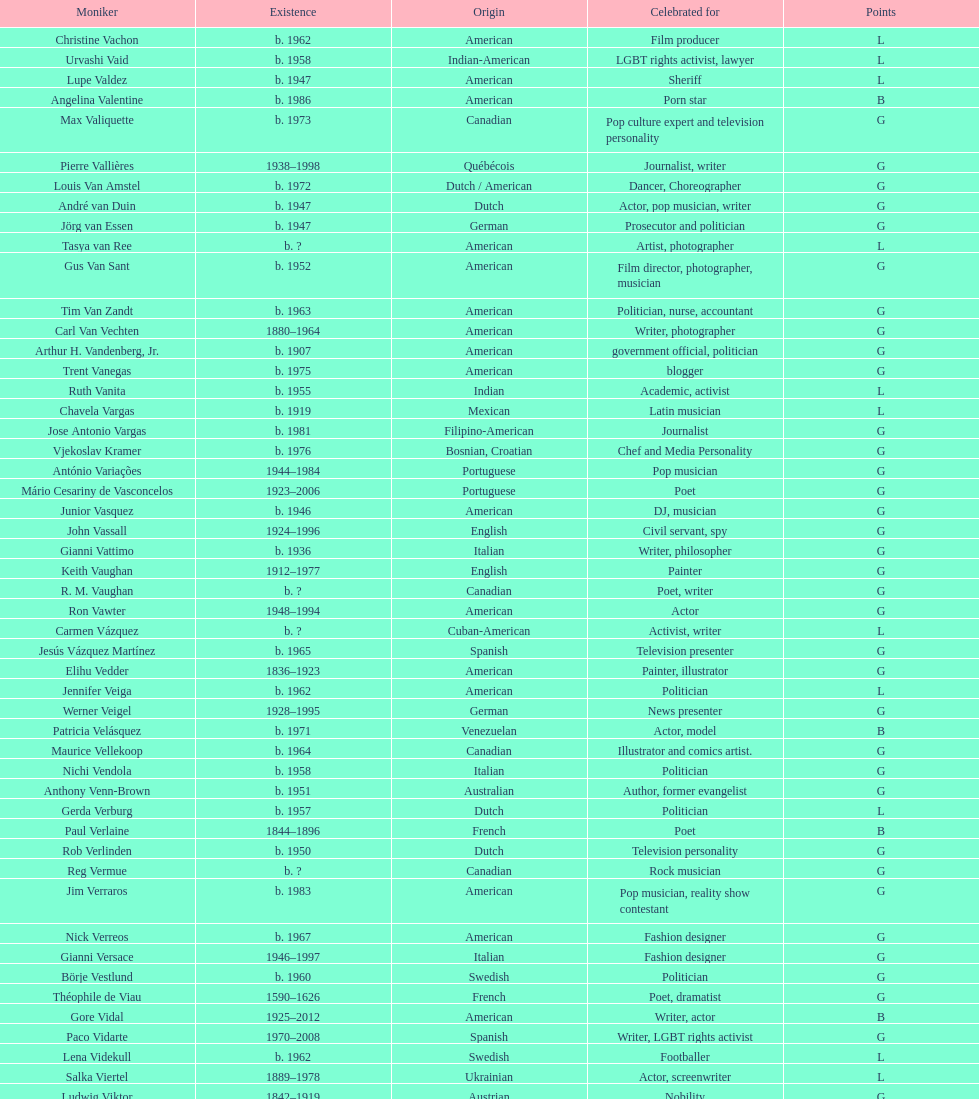Which nationality has the most people associated with it? American. 